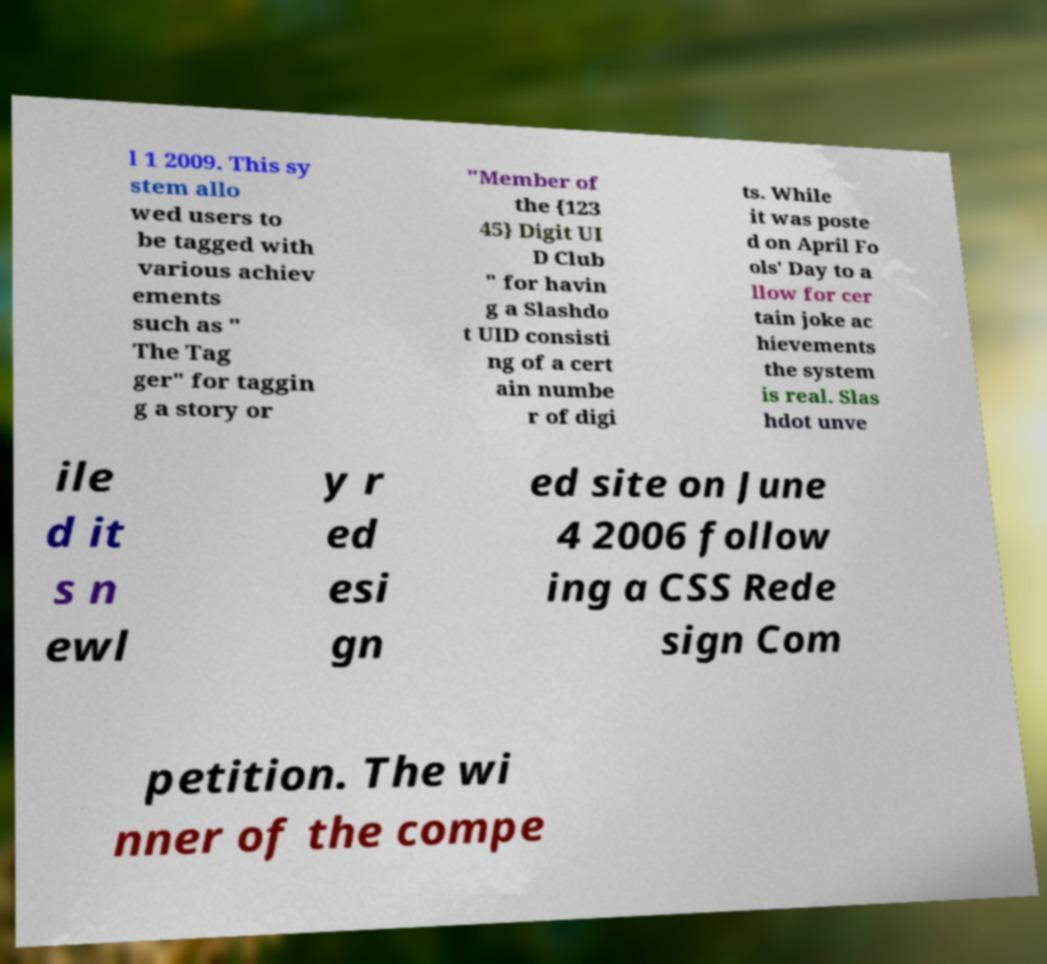I need the written content from this picture converted into text. Can you do that? l 1 2009. This sy stem allo wed users to be tagged with various achiev ements such as " The Tag ger" for taggin g a story or "Member of the {123 45} Digit UI D Club " for havin g a Slashdo t UID consisti ng of a cert ain numbe r of digi ts. While it was poste d on April Fo ols' Day to a llow for cer tain joke ac hievements the system is real. Slas hdot unve ile d it s n ewl y r ed esi gn ed site on June 4 2006 follow ing a CSS Rede sign Com petition. The wi nner of the compe 